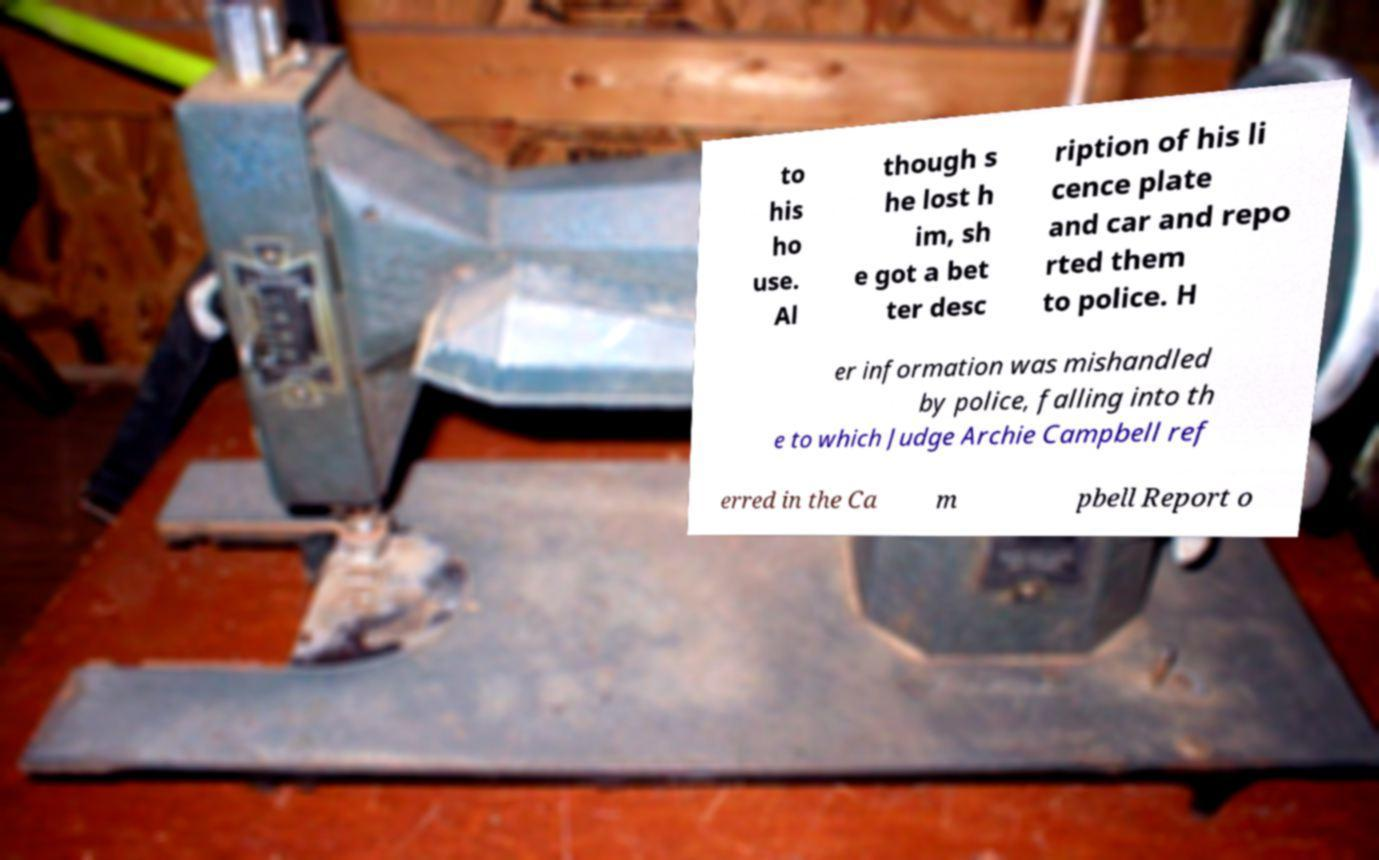What messages or text are displayed in this image? I need them in a readable, typed format. to his ho use. Al though s he lost h im, sh e got a bet ter desc ription of his li cence plate and car and repo rted them to police. H er information was mishandled by police, falling into th e to which Judge Archie Campbell ref erred in the Ca m pbell Report o 